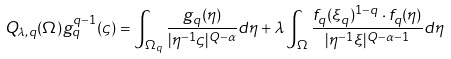<formula> <loc_0><loc_0><loc_500><loc_500>Q _ { \lambda , q } ( \Omega ) g _ { q } ^ { q - 1 } ( \varsigma ) = \int _ { \Omega _ { q } } \frac { g _ { q } ( \eta ) } { | \eta ^ { - 1 } \varsigma | ^ { Q - \alpha } } d \eta + \lambda \int _ { \Omega } \frac { f _ { q } ( \xi _ { q } ) ^ { 1 - q } \cdot f _ { q } ( \eta ) } { | \eta ^ { - 1 } \xi | ^ { Q - \alpha - 1 } } d \eta</formula> 